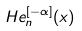<formula> <loc_0><loc_0><loc_500><loc_500>H e _ { n } ^ { [ - \alpha ] } ( x )</formula> 